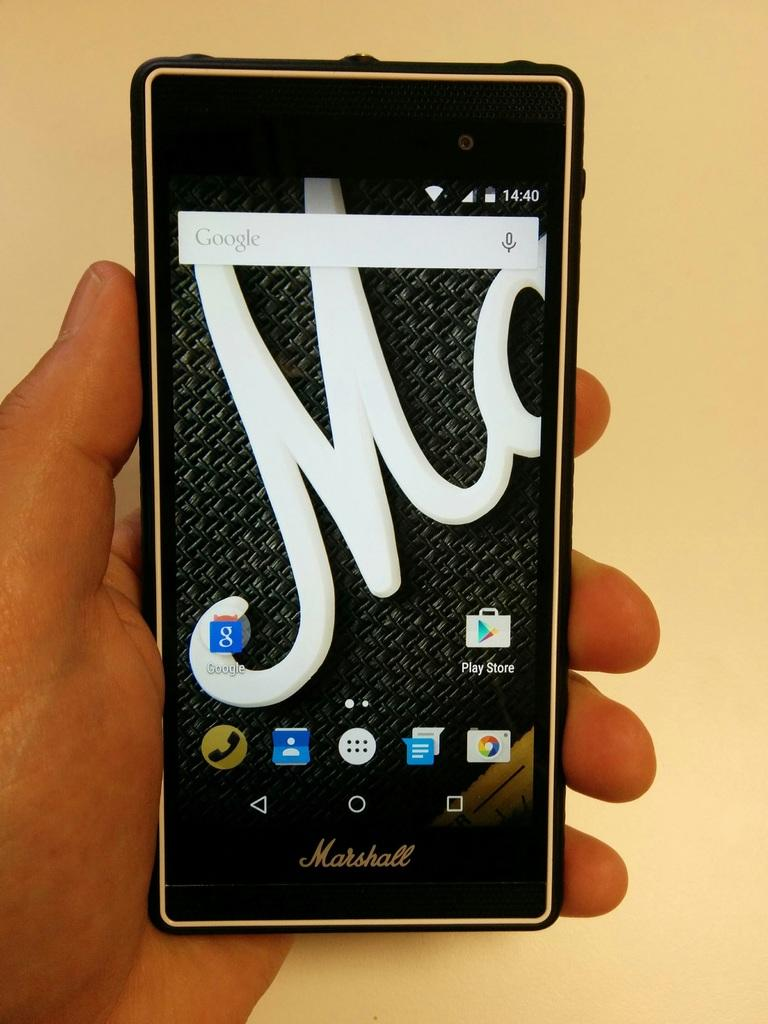<image>
Relay a brief, clear account of the picture shown. A Marshall phone displays a large M as the background screen image. 